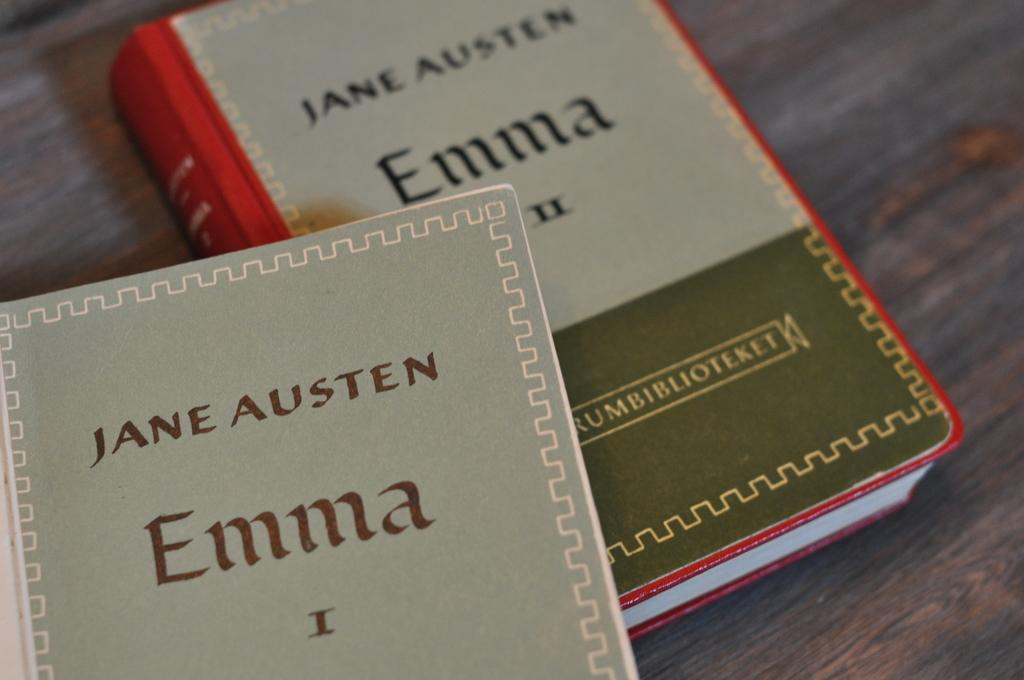Provide a one-sentence caption for the provided image. The book is entitled Emma and is written by Jane Austen. 